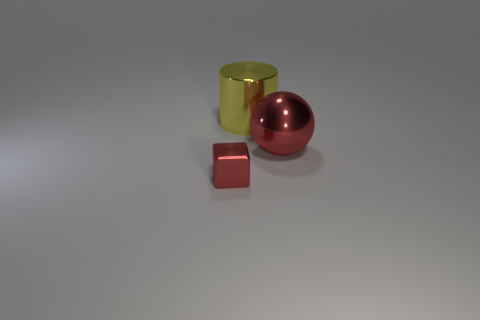Add 2 big red metal balls. How many objects exist? 5 Subtract all cubes. How many objects are left? 2 Add 3 big things. How many big things are left? 5 Add 1 red shiny cubes. How many red shiny cubes exist? 2 Subtract 0 brown cylinders. How many objects are left? 3 Subtract all tiny cyan metal cubes. Subtract all tiny red blocks. How many objects are left? 2 